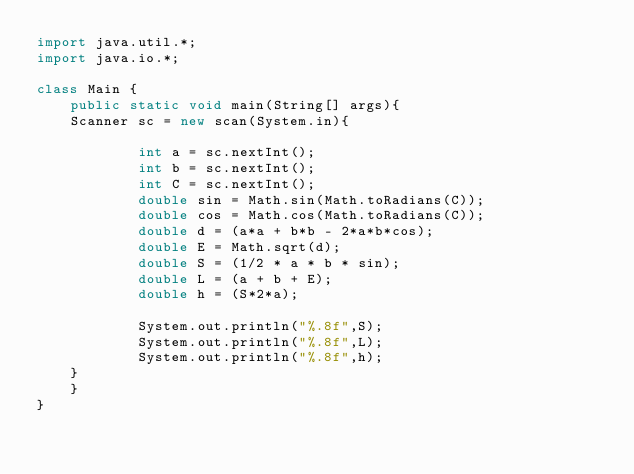<code> <loc_0><loc_0><loc_500><loc_500><_Java_>import java.util.*;
import java.io.*;

class Main {
    public static void main(String[] args){
    Scanner sc = new scan(System.in){
    
            int a = sc.nextInt();
            int b = sc.nextInt();
            int C = sc.nextInt();
            double sin = Math.sin(Math.toRadians(C));
            double cos = Math.cos(Math.toRadians(C));
            double d = (a*a + b*b - 2*a*b*cos); 
            double E = Math.sqrt(d);
            double S = (1/2 * a * b * sin);
            double L = (a + b + E);
            double h = (S*2*a);

            System.out.println("%.8f",S);
            System.out.println("%.8f",L);
            System.out.println("%.8f",h);
    }
    }
}</code> 